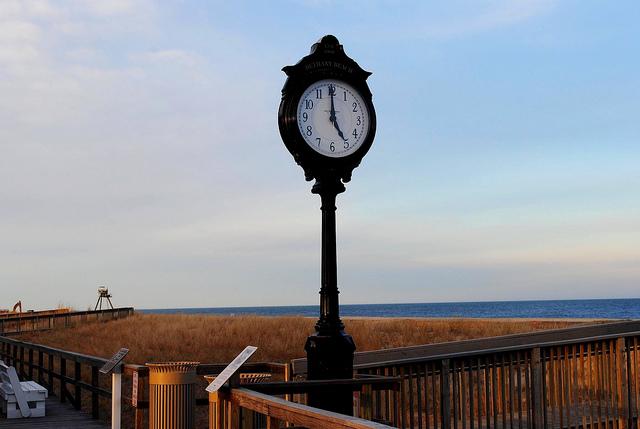What time is it?
Keep it brief. 5:00. Is this near a neighborhood?
Be succinct. No. What time is the clock showing?
Quick response, please. 5:00. What time of year is this?
Answer briefly. Fall. Does this clock display Roman numerals?
Give a very brief answer. No. Are there any people around?
Quick response, please. No. What is off in the distance?
Write a very short answer. Ocean. 